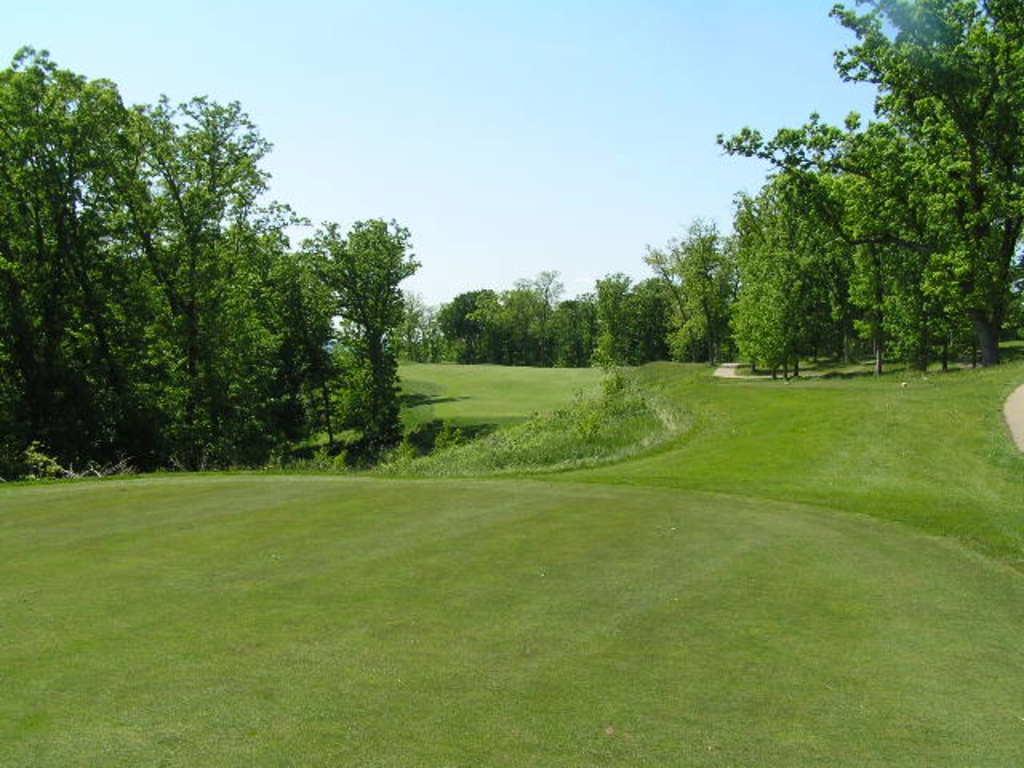Could you give a brief overview of what you see in this image? In this picture we can see some grass on the ground. We can see a few plants and trees in the background. There is the sky on top. 